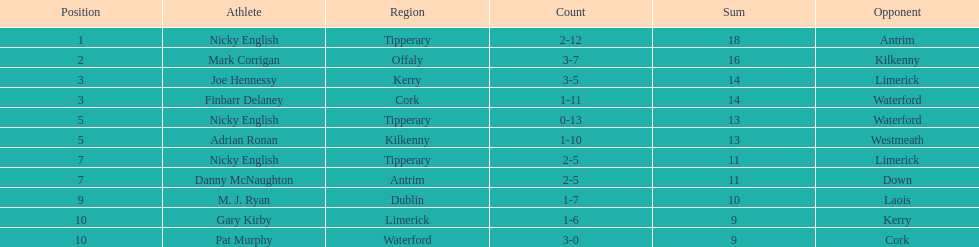What was the average of the totals of nicky english and mark corrigan? 17. 